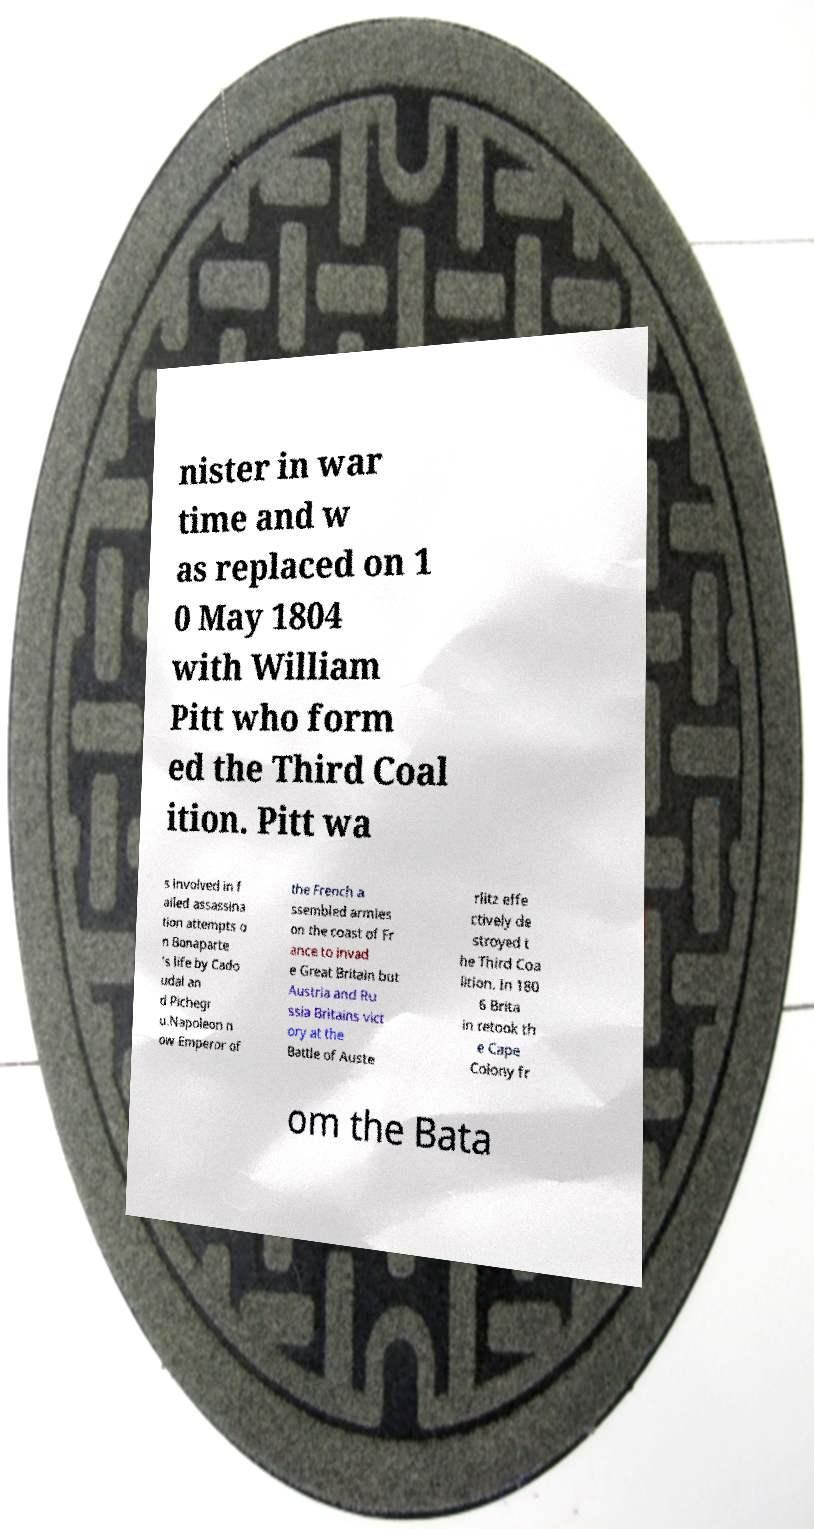Could you extract and type out the text from this image? nister in war time and w as replaced on 1 0 May 1804 with William Pitt who form ed the Third Coal ition. Pitt wa s involved in f ailed assassina tion attempts o n Bonaparte 's life by Cado udal an d Pichegr u.Napoleon n ow Emperor of the French a ssembled armies on the coast of Fr ance to invad e Great Britain but Austria and Ru ssia Britains vict ory at the Battle of Auste rlitz effe ctively de stroyed t he Third Coa lition. In 180 6 Brita in retook th e Cape Colony fr om the Bata 